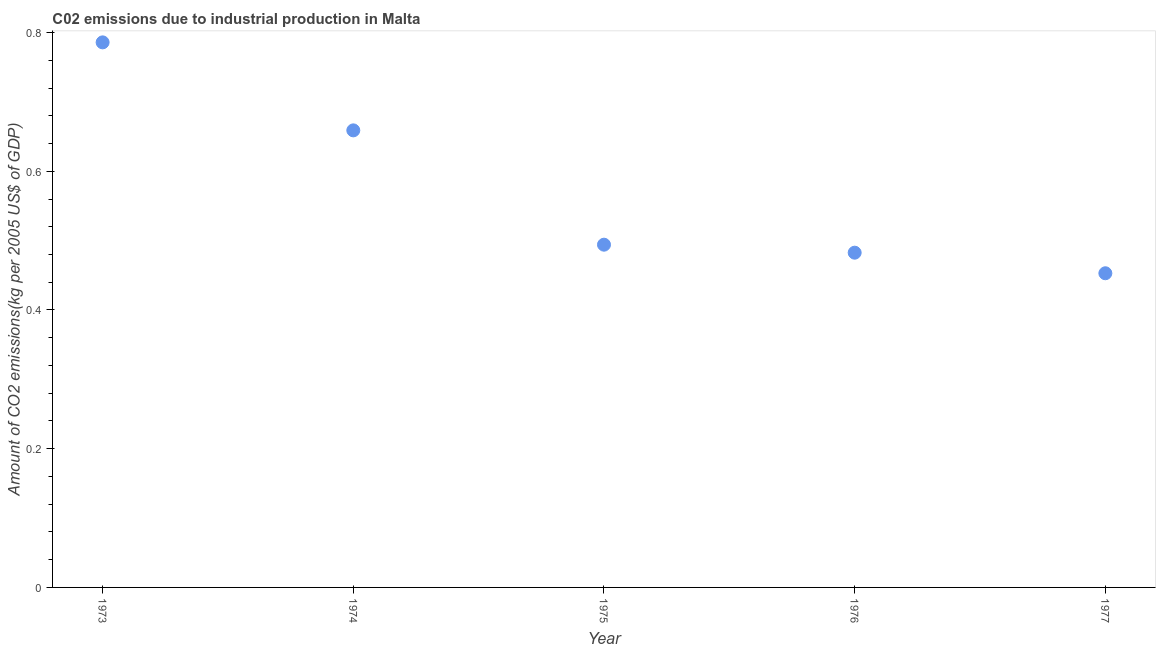What is the amount of co2 emissions in 1973?
Ensure brevity in your answer.  0.79. Across all years, what is the maximum amount of co2 emissions?
Provide a short and direct response. 0.79. Across all years, what is the minimum amount of co2 emissions?
Keep it short and to the point. 0.45. In which year was the amount of co2 emissions minimum?
Offer a terse response. 1977. What is the sum of the amount of co2 emissions?
Keep it short and to the point. 2.87. What is the difference between the amount of co2 emissions in 1974 and 1976?
Your answer should be compact. 0.18. What is the average amount of co2 emissions per year?
Offer a very short reply. 0.57. What is the median amount of co2 emissions?
Your answer should be very brief. 0.49. Do a majority of the years between 1975 and 1973 (inclusive) have amount of co2 emissions greater than 0.7600000000000001 kg per 2005 US$ of GDP?
Provide a succinct answer. No. What is the ratio of the amount of co2 emissions in 1975 to that in 1976?
Your response must be concise. 1.02. Is the amount of co2 emissions in 1973 less than that in 1974?
Offer a very short reply. No. Is the difference between the amount of co2 emissions in 1973 and 1974 greater than the difference between any two years?
Offer a terse response. No. What is the difference between the highest and the second highest amount of co2 emissions?
Offer a very short reply. 0.13. What is the difference between the highest and the lowest amount of co2 emissions?
Your answer should be compact. 0.33. Does the amount of co2 emissions monotonically increase over the years?
Provide a short and direct response. No. How many dotlines are there?
Give a very brief answer. 1. What is the difference between two consecutive major ticks on the Y-axis?
Your answer should be compact. 0.2. Does the graph contain any zero values?
Your answer should be compact. No. What is the title of the graph?
Ensure brevity in your answer.  C02 emissions due to industrial production in Malta. What is the label or title of the Y-axis?
Provide a short and direct response. Amount of CO2 emissions(kg per 2005 US$ of GDP). What is the Amount of CO2 emissions(kg per 2005 US$ of GDP) in 1973?
Provide a succinct answer. 0.79. What is the Amount of CO2 emissions(kg per 2005 US$ of GDP) in 1974?
Offer a terse response. 0.66. What is the Amount of CO2 emissions(kg per 2005 US$ of GDP) in 1975?
Keep it short and to the point. 0.49. What is the Amount of CO2 emissions(kg per 2005 US$ of GDP) in 1976?
Give a very brief answer. 0.48. What is the Amount of CO2 emissions(kg per 2005 US$ of GDP) in 1977?
Keep it short and to the point. 0.45. What is the difference between the Amount of CO2 emissions(kg per 2005 US$ of GDP) in 1973 and 1974?
Provide a short and direct response. 0.13. What is the difference between the Amount of CO2 emissions(kg per 2005 US$ of GDP) in 1973 and 1975?
Provide a succinct answer. 0.29. What is the difference between the Amount of CO2 emissions(kg per 2005 US$ of GDP) in 1973 and 1976?
Provide a succinct answer. 0.3. What is the difference between the Amount of CO2 emissions(kg per 2005 US$ of GDP) in 1973 and 1977?
Make the answer very short. 0.33. What is the difference between the Amount of CO2 emissions(kg per 2005 US$ of GDP) in 1974 and 1975?
Your response must be concise. 0.16. What is the difference between the Amount of CO2 emissions(kg per 2005 US$ of GDP) in 1974 and 1976?
Make the answer very short. 0.18. What is the difference between the Amount of CO2 emissions(kg per 2005 US$ of GDP) in 1974 and 1977?
Provide a succinct answer. 0.21. What is the difference between the Amount of CO2 emissions(kg per 2005 US$ of GDP) in 1975 and 1976?
Provide a short and direct response. 0.01. What is the difference between the Amount of CO2 emissions(kg per 2005 US$ of GDP) in 1975 and 1977?
Your answer should be compact. 0.04. What is the difference between the Amount of CO2 emissions(kg per 2005 US$ of GDP) in 1976 and 1977?
Provide a succinct answer. 0.03. What is the ratio of the Amount of CO2 emissions(kg per 2005 US$ of GDP) in 1973 to that in 1974?
Provide a succinct answer. 1.19. What is the ratio of the Amount of CO2 emissions(kg per 2005 US$ of GDP) in 1973 to that in 1975?
Give a very brief answer. 1.59. What is the ratio of the Amount of CO2 emissions(kg per 2005 US$ of GDP) in 1973 to that in 1976?
Ensure brevity in your answer.  1.63. What is the ratio of the Amount of CO2 emissions(kg per 2005 US$ of GDP) in 1973 to that in 1977?
Your response must be concise. 1.74. What is the ratio of the Amount of CO2 emissions(kg per 2005 US$ of GDP) in 1974 to that in 1975?
Ensure brevity in your answer.  1.33. What is the ratio of the Amount of CO2 emissions(kg per 2005 US$ of GDP) in 1974 to that in 1976?
Your answer should be compact. 1.36. What is the ratio of the Amount of CO2 emissions(kg per 2005 US$ of GDP) in 1974 to that in 1977?
Give a very brief answer. 1.46. What is the ratio of the Amount of CO2 emissions(kg per 2005 US$ of GDP) in 1975 to that in 1976?
Offer a terse response. 1.02. What is the ratio of the Amount of CO2 emissions(kg per 2005 US$ of GDP) in 1975 to that in 1977?
Keep it short and to the point. 1.09. What is the ratio of the Amount of CO2 emissions(kg per 2005 US$ of GDP) in 1976 to that in 1977?
Your response must be concise. 1.06. 